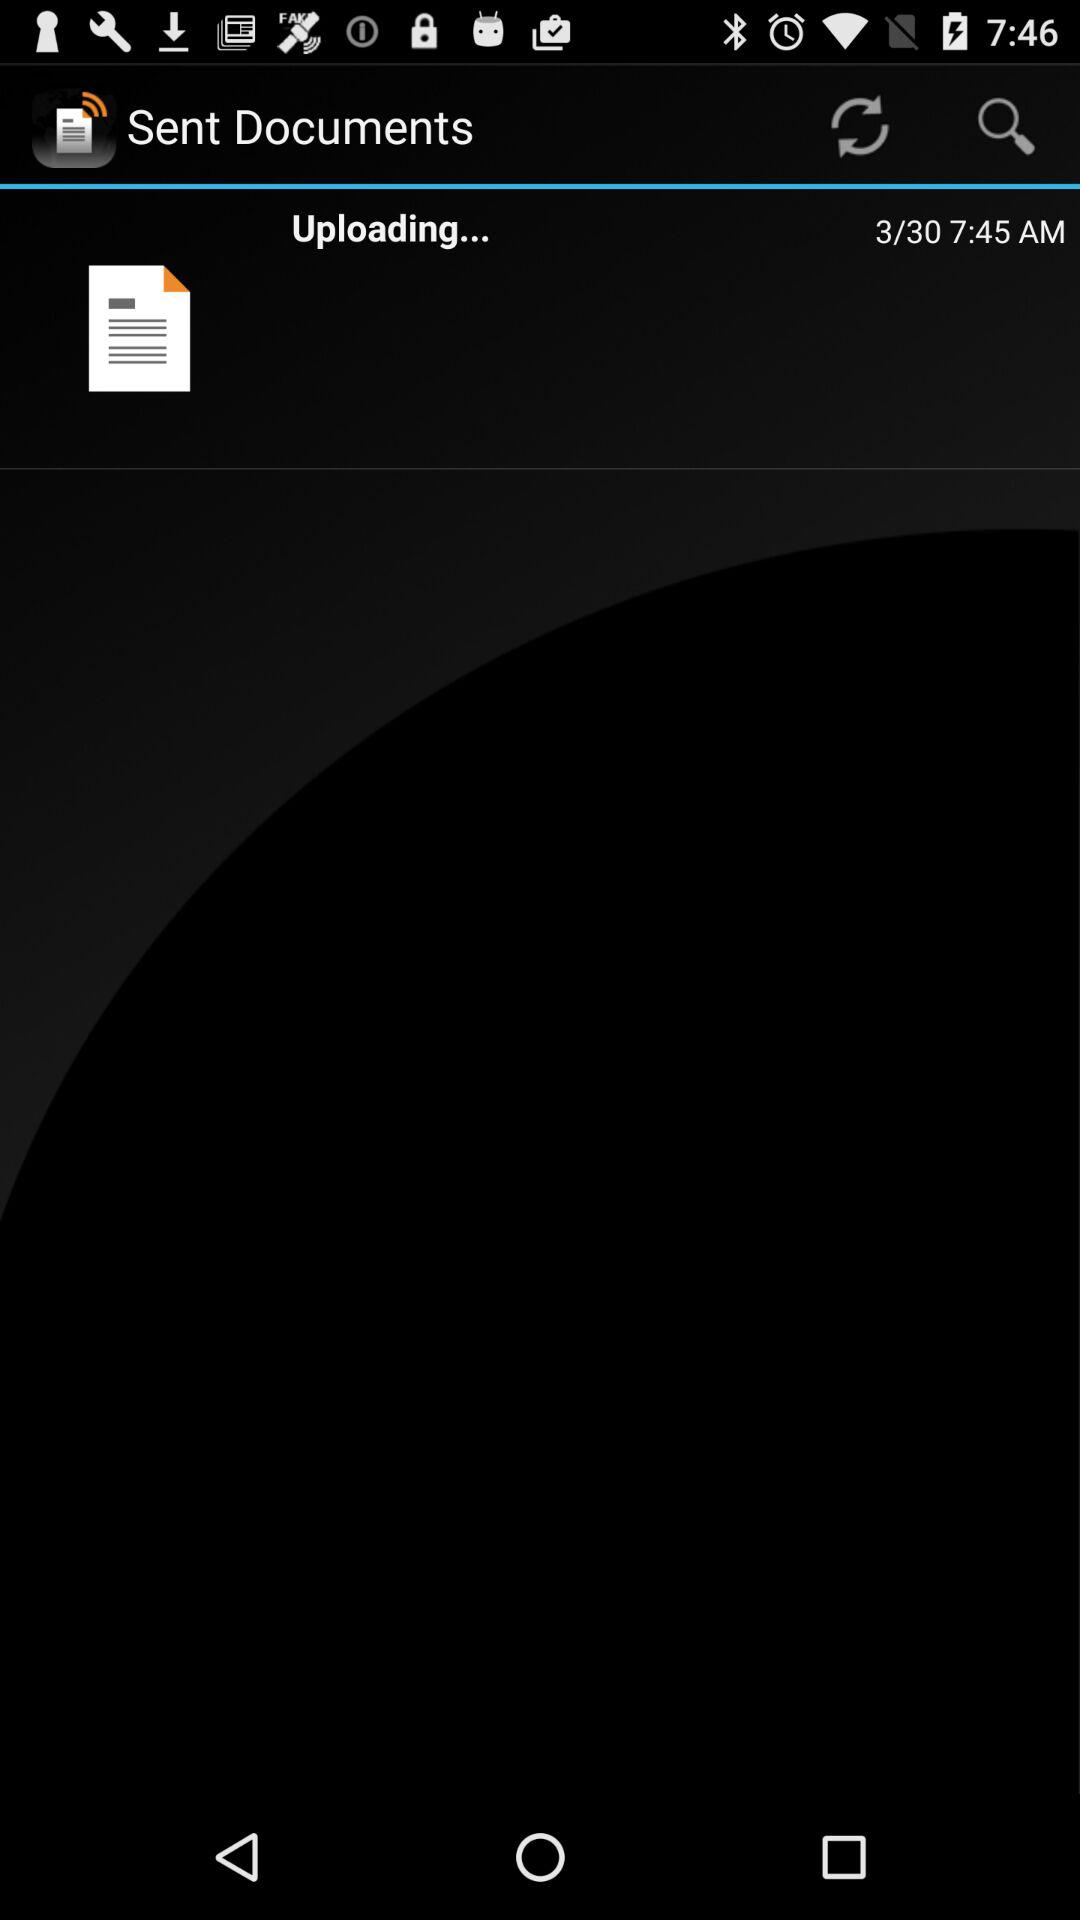At what time is the document uploading? The document is uploading at 7:45 AM. 